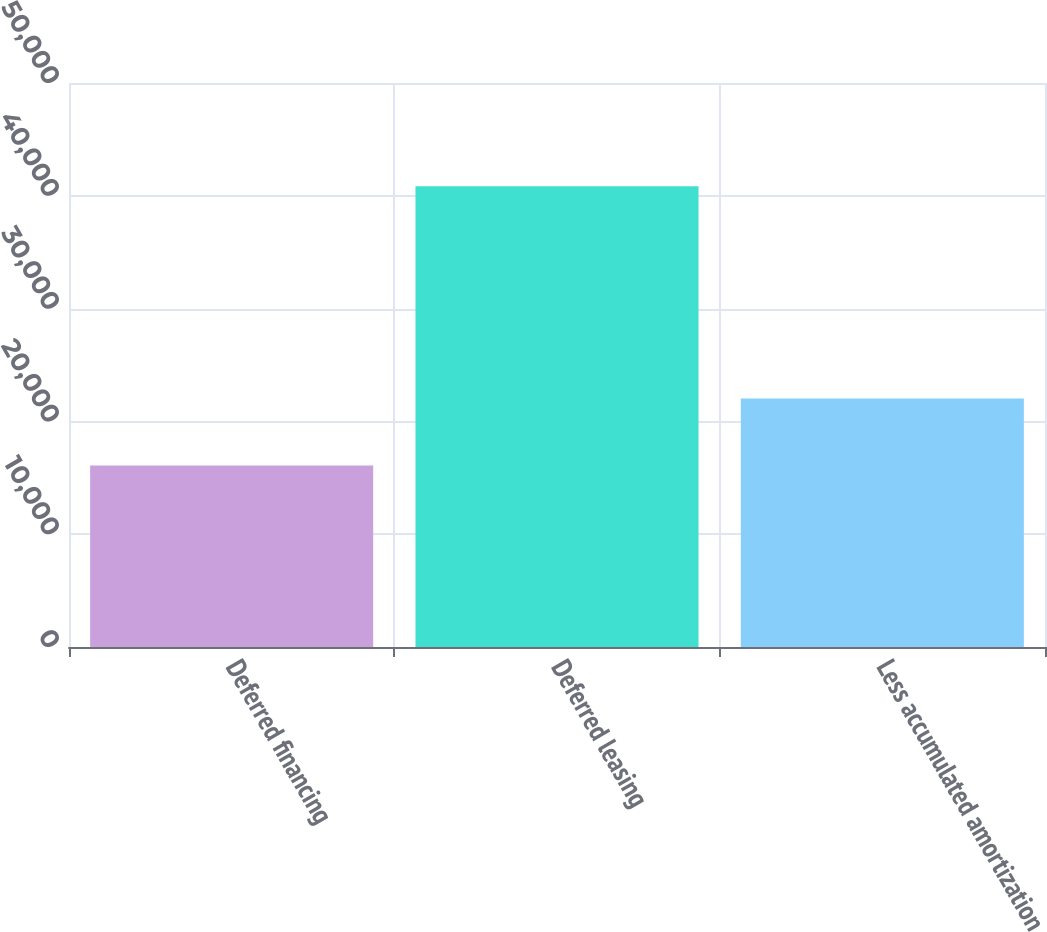<chart> <loc_0><loc_0><loc_500><loc_500><bar_chart><fcel>Deferred financing<fcel>Deferred leasing<fcel>Less accumulated amortization<nl><fcel>16086<fcel>40856<fcel>22041<nl></chart> 